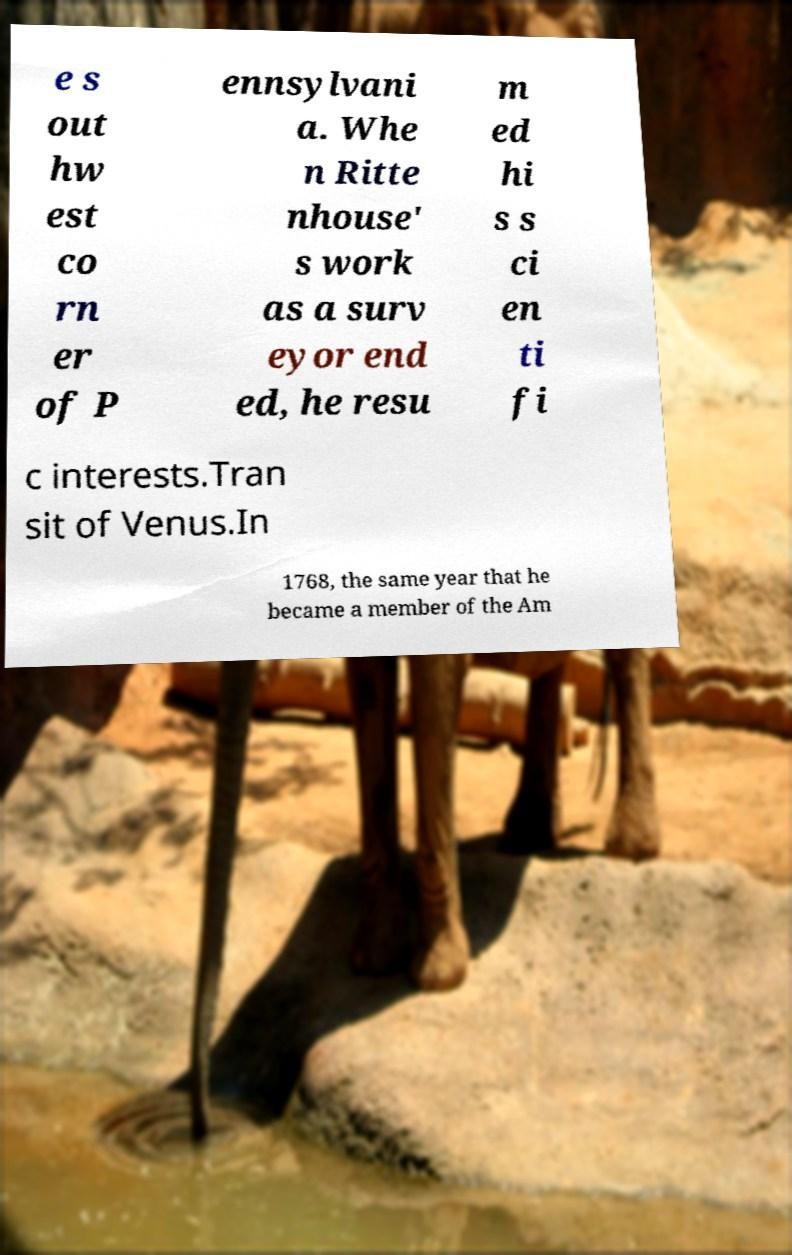Can you accurately transcribe the text from the provided image for me? e s out hw est co rn er of P ennsylvani a. Whe n Ritte nhouse' s work as a surv eyor end ed, he resu m ed hi s s ci en ti fi c interests.Tran sit of Venus.In 1768, the same year that he became a member of the Am 